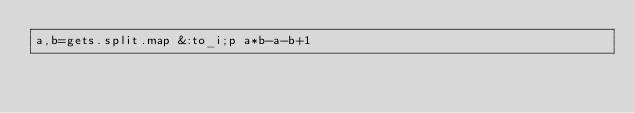<code> <loc_0><loc_0><loc_500><loc_500><_Ruby_>a,b=gets.split.map &:to_i;p a*b-a-b+1</code> 